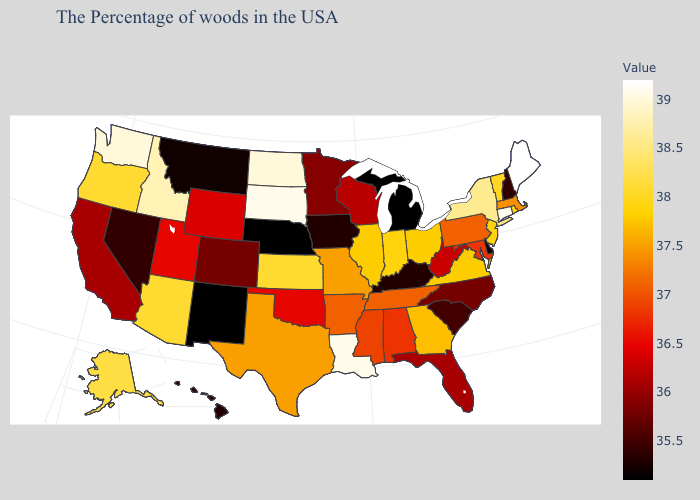Which states hav the highest value in the West?
Give a very brief answer. Washington. Does Texas have a lower value than Hawaii?
Give a very brief answer. No. Among the states that border Utah , does Nevada have the highest value?
Concise answer only. No. Which states have the lowest value in the South?
Answer briefly. Delaware. Among the states that border Alabama , does Florida have the lowest value?
Write a very short answer. Yes. Does Nebraska have the lowest value in the USA?
Quick response, please. Yes. 